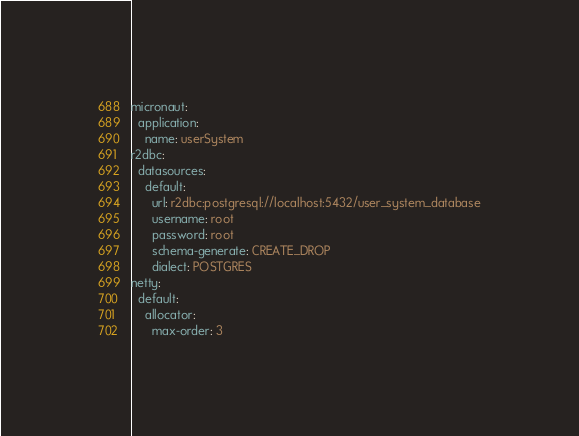Convert code to text. <code><loc_0><loc_0><loc_500><loc_500><_YAML_>micronaut:
  application:
    name: userSystem
r2dbc:
  datasources:
    default:
      url: r2dbc:postgresql://localhost:5432/user_system_database
      username: root
      password: root
      schema-generate: CREATE_DROP
      dialect: POSTGRES
netty:
  default:
    allocator:
      max-order: 3
</code> 